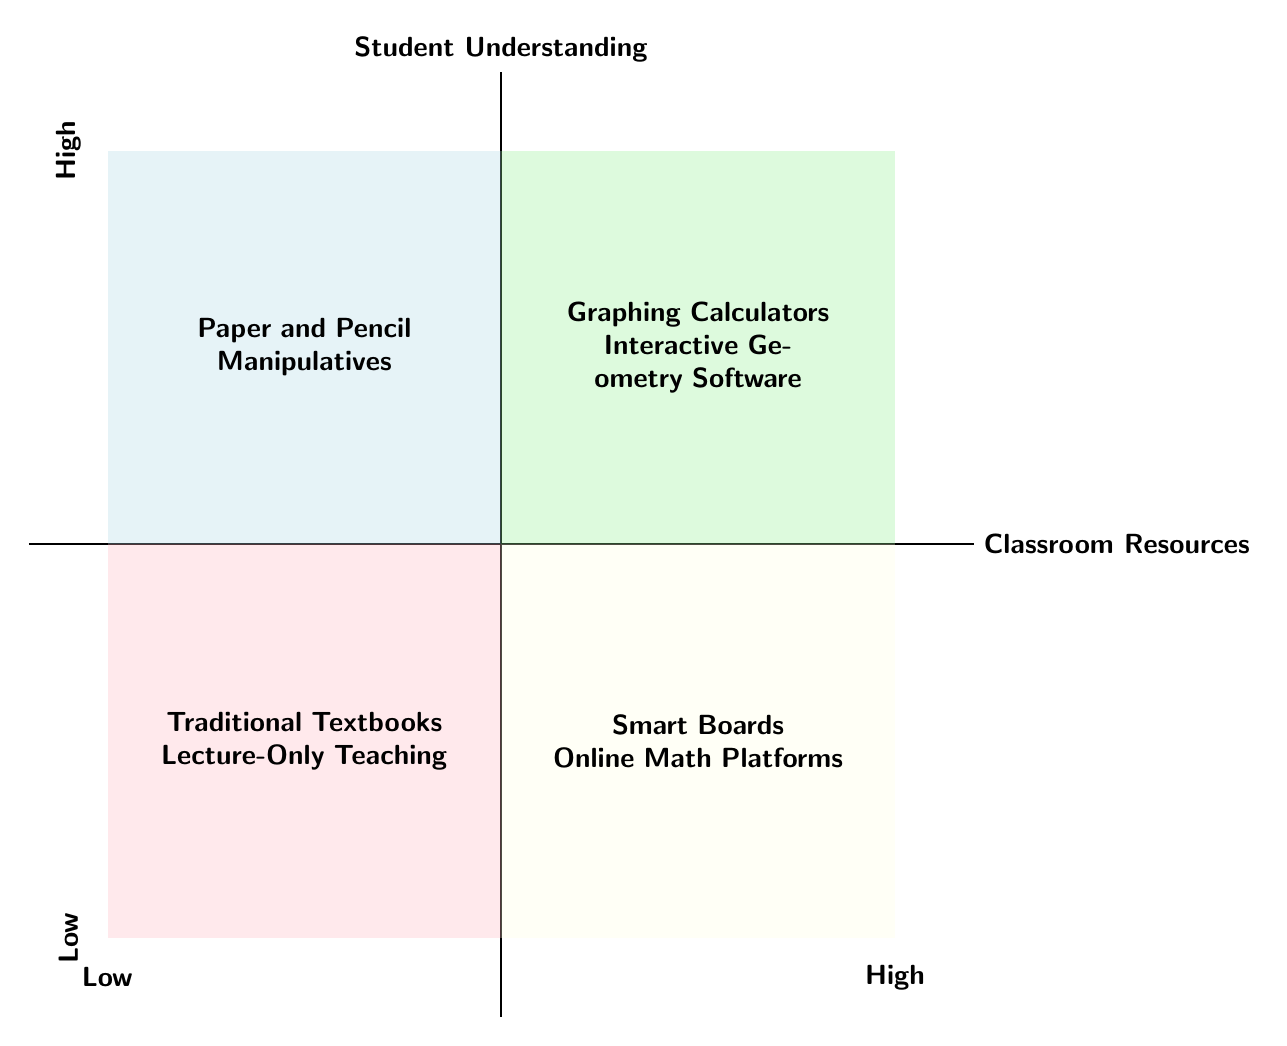What are the two resources in the High Classroom Resources - High Student Understanding quadrant? In the diagram's top-right quadrant, the listed resources are "Graphing Calculators" and "Interactive Geometry Software".
Answer: Graphing Calculators, Interactive Geometry Software What quadrant contains Traditional Textbooks? Traditional Textbooks are located in the Low Classroom Resources - Low Student Understanding quadrant, which is in the bottom-left part of the diagram.
Answer: Low Classroom Resources - Low Student Understanding Which resource has Low Classroom Resources but High Student Understanding? According to the diagram, "Paper and Pencil" and "Manipulatives (e.g., algebra tiles)" are found in the quadrant representing Low Classroom Resources but High Student Understanding.
Answer: Paper and Pencil, Manipulatives How many resources are listed in the High Classroom Resources - Low Student Understanding quadrant? There are two resources noted in the High Classroom Resources - Low Student Understanding quadrant: "Smart Boards" and "Online Subscription-Based Math Platforms".
Answer: 2 In which quadrant would you find Lecture-Only Teaching? The resource "Lecture-Only Teaching" is part of the Low Classroom Resources - Low Student Understanding quadrant, located in the bottom-left section of the diagram.
Answer: Low Classroom Resources - Low Student Understanding What can be inferred about the relationship between Classroom Resources and Student Understanding based on the diagram? The quadrants indicate that higher classroom resources are generally associated with higher student understanding, while lower resources correlate with lower understanding; however, some tools can still lead to high understanding with minimal resources.
Answer: Positive correlation, with exceptions 